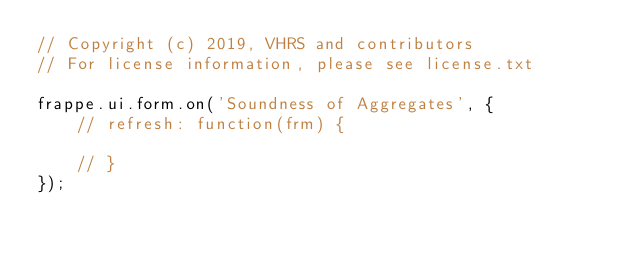<code> <loc_0><loc_0><loc_500><loc_500><_JavaScript_>// Copyright (c) 2019, VHRS and contributors
// For license information, please see license.txt

frappe.ui.form.on('Soundness of Aggregates', {
	// refresh: function(frm) {

	// }
});
</code> 